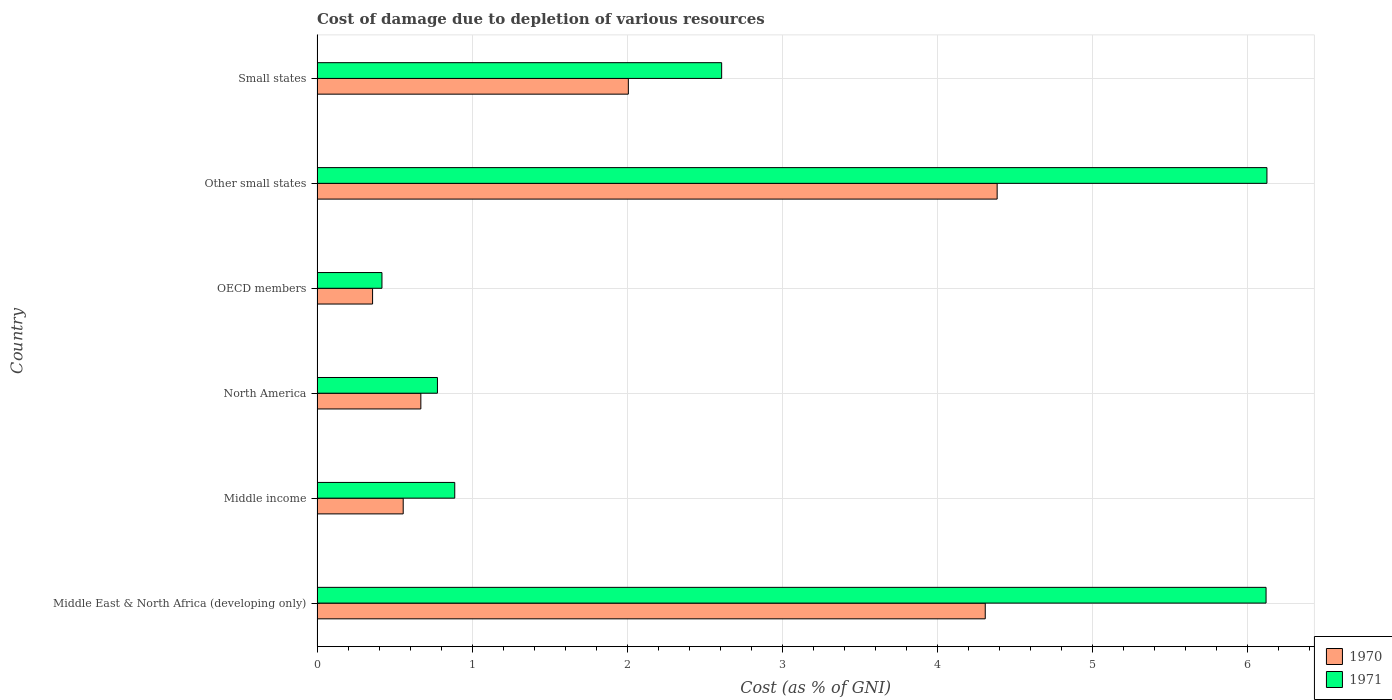Are the number of bars per tick equal to the number of legend labels?
Your answer should be compact. Yes. What is the label of the 2nd group of bars from the top?
Provide a succinct answer. Other small states. What is the cost of damage caused due to the depletion of various resources in 1971 in Small states?
Offer a terse response. 2.61. Across all countries, what is the maximum cost of damage caused due to the depletion of various resources in 1970?
Your answer should be compact. 4.39. Across all countries, what is the minimum cost of damage caused due to the depletion of various resources in 1971?
Your answer should be compact. 0.42. In which country was the cost of damage caused due to the depletion of various resources in 1971 maximum?
Your answer should be compact. Other small states. What is the total cost of damage caused due to the depletion of various resources in 1971 in the graph?
Your response must be concise. 16.94. What is the difference between the cost of damage caused due to the depletion of various resources in 1971 in Middle income and that in Small states?
Provide a short and direct response. -1.72. What is the difference between the cost of damage caused due to the depletion of various resources in 1971 in Small states and the cost of damage caused due to the depletion of various resources in 1970 in Middle East & North Africa (developing only)?
Provide a succinct answer. -1.7. What is the average cost of damage caused due to the depletion of various resources in 1970 per country?
Provide a succinct answer. 2.05. What is the difference between the cost of damage caused due to the depletion of various resources in 1970 and cost of damage caused due to the depletion of various resources in 1971 in North America?
Provide a succinct answer. -0.11. What is the ratio of the cost of damage caused due to the depletion of various resources in 1971 in OECD members to that in Other small states?
Offer a terse response. 0.07. What is the difference between the highest and the second highest cost of damage caused due to the depletion of various resources in 1970?
Provide a succinct answer. 0.08. What is the difference between the highest and the lowest cost of damage caused due to the depletion of various resources in 1971?
Your response must be concise. 5.71. In how many countries, is the cost of damage caused due to the depletion of various resources in 1970 greater than the average cost of damage caused due to the depletion of various resources in 1970 taken over all countries?
Your answer should be very brief. 2. What does the 1st bar from the top in North America represents?
Your response must be concise. 1971. What does the 2nd bar from the bottom in Small states represents?
Provide a succinct answer. 1971. How many bars are there?
Offer a terse response. 12. What is the difference between two consecutive major ticks on the X-axis?
Offer a terse response. 1. How many legend labels are there?
Your answer should be very brief. 2. What is the title of the graph?
Offer a terse response. Cost of damage due to depletion of various resources. Does "1983" appear as one of the legend labels in the graph?
Ensure brevity in your answer.  No. What is the label or title of the X-axis?
Give a very brief answer. Cost (as % of GNI). What is the label or title of the Y-axis?
Offer a very short reply. Country. What is the Cost (as % of GNI) in 1970 in Middle East & North Africa (developing only)?
Ensure brevity in your answer.  4.31. What is the Cost (as % of GNI) in 1971 in Middle East & North Africa (developing only)?
Offer a terse response. 6.12. What is the Cost (as % of GNI) in 1970 in Middle income?
Ensure brevity in your answer.  0.56. What is the Cost (as % of GNI) in 1971 in Middle income?
Ensure brevity in your answer.  0.89. What is the Cost (as % of GNI) of 1970 in North America?
Your answer should be very brief. 0.67. What is the Cost (as % of GNI) in 1971 in North America?
Ensure brevity in your answer.  0.78. What is the Cost (as % of GNI) in 1970 in OECD members?
Offer a very short reply. 0.36. What is the Cost (as % of GNI) of 1971 in OECD members?
Keep it short and to the point. 0.42. What is the Cost (as % of GNI) in 1970 in Other small states?
Your response must be concise. 4.39. What is the Cost (as % of GNI) in 1971 in Other small states?
Your answer should be compact. 6.13. What is the Cost (as % of GNI) of 1970 in Small states?
Your answer should be compact. 2.01. What is the Cost (as % of GNI) of 1971 in Small states?
Offer a terse response. 2.61. Across all countries, what is the maximum Cost (as % of GNI) in 1970?
Your answer should be very brief. 4.39. Across all countries, what is the maximum Cost (as % of GNI) of 1971?
Provide a short and direct response. 6.13. Across all countries, what is the minimum Cost (as % of GNI) in 1970?
Your response must be concise. 0.36. Across all countries, what is the minimum Cost (as % of GNI) of 1971?
Provide a short and direct response. 0.42. What is the total Cost (as % of GNI) in 1970 in the graph?
Ensure brevity in your answer.  12.28. What is the total Cost (as % of GNI) of 1971 in the graph?
Your answer should be very brief. 16.94. What is the difference between the Cost (as % of GNI) of 1970 in Middle East & North Africa (developing only) and that in Middle income?
Make the answer very short. 3.75. What is the difference between the Cost (as % of GNI) of 1971 in Middle East & North Africa (developing only) and that in Middle income?
Make the answer very short. 5.23. What is the difference between the Cost (as % of GNI) in 1970 in Middle East & North Africa (developing only) and that in North America?
Give a very brief answer. 3.64. What is the difference between the Cost (as % of GNI) in 1971 in Middle East & North Africa (developing only) and that in North America?
Offer a terse response. 5.34. What is the difference between the Cost (as % of GNI) in 1970 in Middle East & North Africa (developing only) and that in OECD members?
Ensure brevity in your answer.  3.95. What is the difference between the Cost (as % of GNI) in 1971 in Middle East & North Africa (developing only) and that in OECD members?
Keep it short and to the point. 5.7. What is the difference between the Cost (as % of GNI) in 1970 in Middle East & North Africa (developing only) and that in Other small states?
Provide a succinct answer. -0.08. What is the difference between the Cost (as % of GNI) in 1971 in Middle East & North Africa (developing only) and that in Other small states?
Offer a very short reply. -0.01. What is the difference between the Cost (as % of GNI) of 1970 in Middle East & North Africa (developing only) and that in Small states?
Give a very brief answer. 2.3. What is the difference between the Cost (as % of GNI) in 1971 in Middle East & North Africa (developing only) and that in Small states?
Offer a terse response. 3.51. What is the difference between the Cost (as % of GNI) of 1970 in Middle income and that in North America?
Ensure brevity in your answer.  -0.11. What is the difference between the Cost (as % of GNI) in 1971 in Middle income and that in North America?
Keep it short and to the point. 0.11. What is the difference between the Cost (as % of GNI) of 1970 in Middle income and that in OECD members?
Your answer should be very brief. 0.2. What is the difference between the Cost (as % of GNI) in 1971 in Middle income and that in OECD members?
Offer a terse response. 0.47. What is the difference between the Cost (as % of GNI) of 1970 in Middle income and that in Other small states?
Provide a succinct answer. -3.83. What is the difference between the Cost (as % of GNI) of 1971 in Middle income and that in Other small states?
Give a very brief answer. -5.24. What is the difference between the Cost (as % of GNI) in 1970 in Middle income and that in Small states?
Provide a short and direct response. -1.45. What is the difference between the Cost (as % of GNI) in 1971 in Middle income and that in Small states?
Your answer should be compact. -1.72. What is the difference between the Cost (as % of GNI) in 1970 in North America and that in OECD members?
Ensure brevity in your answer.  0.31. What is the difference between the Cost (as % of GNI) in 1971 in North America and that in OECD members?
Keep it short and to the point. 0.36. What is the difference between the Cost (as % of GNI) of 1970 in North America and that in Other small states?
Offer a terse response. -3.72. What is the difference between the Cost (as % of GNI) in 1971 in North America and that in Other small states?
Provide a short and direct response. -5.35. What is the difference between the Cost (as % of GNI) in 1970 in North America and that in Small states?
Provide a short and direct response. -1.34. What is the difference between the Cost (as % of GNI) in 1971 in North America and that in Small states?
Provide a short and direct response. -1.83. What is the difference between the Cost (as % of GNI) in 1970 in OECD members and that in Other small states?
Your answer should be compact. -4.03. What is the difference between the Cost (as % of GNI) in 1971 in OECD members and that in Other small states?
Offer a very short reply. -5.71. What is the difference between the Cost (as % of GNI) of 1970 in OECD members and that in Small states?
Provide a succinct answer. -1.65. What is the difference between the Cost (as % of GNI) of 1971 in OECD members and that in Small states?
Make the answer very short. -2.19. What is the difference between the Cost (as % of GNI) in 1970 in Other small states and that in Small states?
Your response must be concise. 2.38. What is the difference between the Cost (as % of GNI) of 1971 in Other small states and that in Small states?
Ensure brevity in your answer.  3.52. What is the difference between the Cost (as % of GNI) of 1970 in Middle East & North Africa (developing only) and the Cost (as % of GNI) of 1971 in Middle income?
Give a very brief answer. 3.42. What is the difference between the Cost (as % of GNI) in 1970 in Middle East & North Africa (developing only) and the Cost (as % of GNI) in 1971 in North America?
Your answer should be compact. 3.53. What is the difference between the Cost (as % of GNI) of 1970 in Middle East & North Africa (developing only) and the Cost (as % of GNI) of 1971 in OECD members?
Your answer should be very brief. 3.89. What is the difference between the Cost (as % of GNI) in 1970 in Middle East & North Africa (developing only) and the Cost (as % of GNI) in 1971 in Other small states?
Your response must be concise. -1.82. What is the difference between the Cost (as % of GNI) of 1970 in Middle East & North Africa (developing only) and the Cost (as % of GNI) of 1971 in Small states?
Make the answer very short. 1.7. What is the difference between the Cost (as % of GNI) of 1970 in Middle income and the Cost (as % of GNI) of 1971 in North America?
Ensure brevity in your answer.  -0.22. What is the difference between the Cost (as % of GNI) in 1970 in Middle income and the Cost (as % of GNI) in 1971 in OECD members?
Your answer should be very brief. 0.14. What is the difference between the Cost (as % of GNI) in 1970 in Middle income and the Cost (as % of GNI) in 1971 in Other small states?
Ensure brevity in your answer.  -5.57. What is the difference between the Cost (as % of GNI) of 1970 in Middle income and the Cost (as % of GNI) of 1971 in Small states?
Offer a terse response. -2.05. What is the difference between the Cost (as % of GNI) of 1970 in North America and the Cost (as % of GNI) of 1971 in OECD members?
Your response must be concise. 0.25. What is the difference between the Cost (as % of GNI) of 1970 in North America and the Cost (as % of GNI) of 1971 in Other small states?
Provide a short and direct response. -5.46. What is the difference between the Cost (as % of GNI) in 1970 in North America and the Cost (as % of GNI) in 1971 in Small states?
Keep it short and to the point. -1.94. What is the difference between the Cost (as % of GNI) in 1970 in OECD members and the Cost (as % of GNI) in 1971 in Other small states?
Make the answer very short. -5.77. What is the difference between the Cost (as % of GNI) in 1970 in OECD members and the Cost (as % of GNI) in 1971 in Small states?
Make the answer very short. -2.25. What is the difference between the Cost (as % of GNI) of 1970 in Other small states and the Cost (as % of GNI) of 1971 in Small states?
Provide a short and direct response. 1.78. What is the average Cost (as % of GNI) in 1970 per country?
Keep it short and to the point. 2.05. What is the average Cost (as % of GNI) of 1971 per country?
Ensure brevity in your answer.  2.82. What is the difference between the Cost (as % of GNI) of 1970 and Cost (as % of GNI) of 1971 in Middle East & North Africa (developing only)?
Your response must be concise. -1.81. What is the difference between the Cost (as % of GNI) in 1970 and Cost (as % of GNI) in 1971 in Middle income?
Give a very brief answer. -0.33. What is the difference between the Cost (as % of GNI) in 1970 and Cost (as % of GNI) in 1971 in North America?
Your answer should be very brief. -0.11. What is the difference between the Cost (as % of GNI) in 1970 and Cost (as % of GNI) in 1971 in OECD members?
Your answer should be compact. -0.06. What is the difference between the Cost (as % of GNI) of 1970 and Cost (as % of GNI) of 1971 in Other small states?
Your answer should be very brief. -1.74. What is the difference between the Cost (as % of GNI) in 1970 and Cost (as % of GNI) in 1971 in Small states?
Offer a very short reply. -0.6. What is the ratio of the Cost (as % of GNI) of 1970 in Middle East & North Africa (developing only) to that in Middle income?
Give a very brief answer. 7.76. What is the ratio of the Cost (as % of GNI) of 1971 in Middle East & North Africa (developing only) to that in Middle income?
Provide a short and direct response. 6.89. What is the ratio of the Cost (as % of GNI) in 1970 in Middle East & North Africa (developing only) to that in North America?
Ensure brevity in your answer.  6.44. What is the ratio of the Cost (as % of GNI) in 1971 in Middle East & North Africa (developing only) to that in North America?
Your answer should be compact. 7.88. What is the ratio of the Cost (as % of GNI) in 1970 in Middle East & North Africa (developing only) to that in OECD members?
Your answer should be compact. 12.03. What is the ratio of the Cost (as % of GNI) in 1971 in Middle East & North Africa (developing only) to that in OECD members?
Offer a very short reply. 14.62. What is the ratio of the Cost (as % of GNI) of 1970 in Middle East & North Africa (developing only) to that in Other small states?
Offer a very short reply. 0.98. What is the ratio of the Cost (as % of GNI) of 1970 in Middle East & North Africa (developing only) to that in Small states?
Offer a very short reply. 2.15. What is the ratio of the Cost (as % of GNI) in 1971 in Middle East & North Africa (developing only) to that in Small states?
Give a very brief answer. 2.35. What is the ratio of the Cost (as % of GNI) of 1970 in Middle income to that in North America?
Provide a short and direct response. 0.83. What is the ratio of the Cost (as % of GNI) in 1971 in Middle income to that in North America?
Your response must be concise. 1.14. What is the ratio of the Cost (as % of GNI) of 1970 in Middle income to that in OECD members?
Give a very brief answer. 1.55. What is the ratio of the Cost (as % of GNI) in 1971 in Middle income to that in OECD members?
Keep it short and to the point. 2.12. What is the ratio of the Cost (as % of GNI) in 1970 in Middle income to that in Other small states?
Provide a succinct answer. 0.13. What is the ratio of the Cost (as % of GNI) in 1971 in Middle income to that in Other small states?
Offer a very short reply. 0.14. What is the ratio of the Cost (as % of GNI) of 1970 in Middle income to that in Small states?
Provide a succinct answer. 0.28. What is the ratio of the Cost (as % of GNI) in 1971 in Middle income to that in Small states?
Offer a terse response. 0.34. What is the ratio of the Cost (as % of GNI) of 1970 in North America to that in OECD members?
Keep it short and to the point. 1.87. What is the ratio of the Cost (as % of GNI) of 1971 in North America to that in OECD members?
Provide a short and direct response. 1.85. What is the ratio of the Cost (as % of GNI) of 1970 in North America to that in Other small states?
Your answer should be very brief. 0.15. What is the ratio of the Cost (as % of GNI) of 1971 in North America to that in Other small states?
Ensure brevity in your answer.  0.13. What is the ratio of the Cost (as % of GNI) of 1970 in North America to that in Small states?
Give a very brief answer. 0.33. What is the ratio of the Cost (as % of GNI) in 1971 in North America to that in Small states?
Offer a very short reply. 0.3. What is the ratio of the Cost (as % of GNI) in 1970 in OECD members to that in Other small states?
Offer a terse response. 0.08. What is the ratio of the Cost (as % of GNI) of 1971 in OECD members to that in Other small states?
Provide a short and direct response. 0.07. What is the ratio of the Cost (as % of GNI) of 1970 in OECD members to that in Small states?
Your answer should be very brief. 0.18. What is the ratio of the Cost (as % of GNI) of 1971 in OECD members to that in Small states?
Ensure brevity in your answer.  0.16. What is the ratio of the Cost (as % of GNI) in 1970 in Other small states to that in Small states?
Your response must be concise. 2.18. What is the ratio of the Cost (as % of GNI) in 1971 in Other small states to that in Small states?
Give a very brief answer. 2.35. What is the difference between the highest and the second highest Cost (as % of GNI) of 1970?
Your response must be concise. 0.08. What is the difference between the highest and the second highest Cost (as % of GNI) of 1971?
Your response must be concise. 0.01. What is the difference between the highest and the lowest Cost (as % of GNI) in 1970?
Offer a terse response. 4.03. What is the difference between the highest and the lowest Cost (as % of GNI) of 1971?
Your response must be concise. 5.71. 